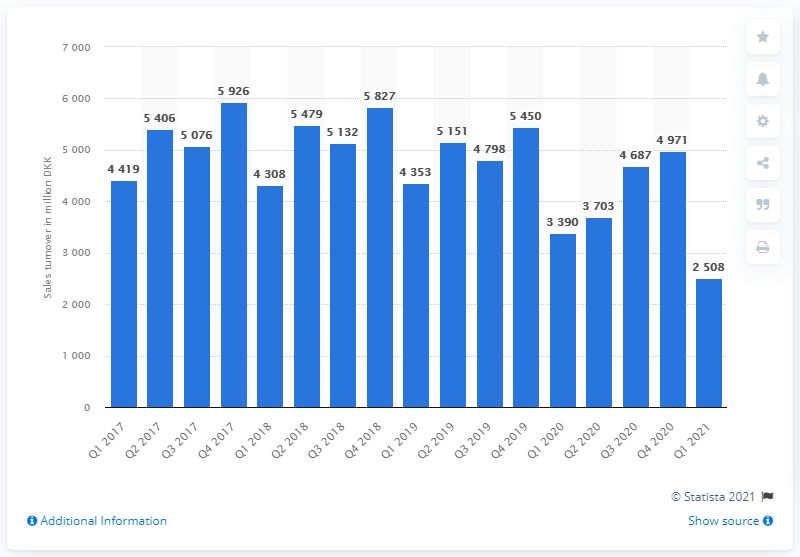Mention a couple of crucial points in this snapshot. According to the sales turnover of clothing in Denmark during the first quarter of 2021, a total of 5,926 units of clothing were sold. According to the most recent data available, the sales turnover of clothing in Denmark during the last quarter of 2017 was 5,926. 